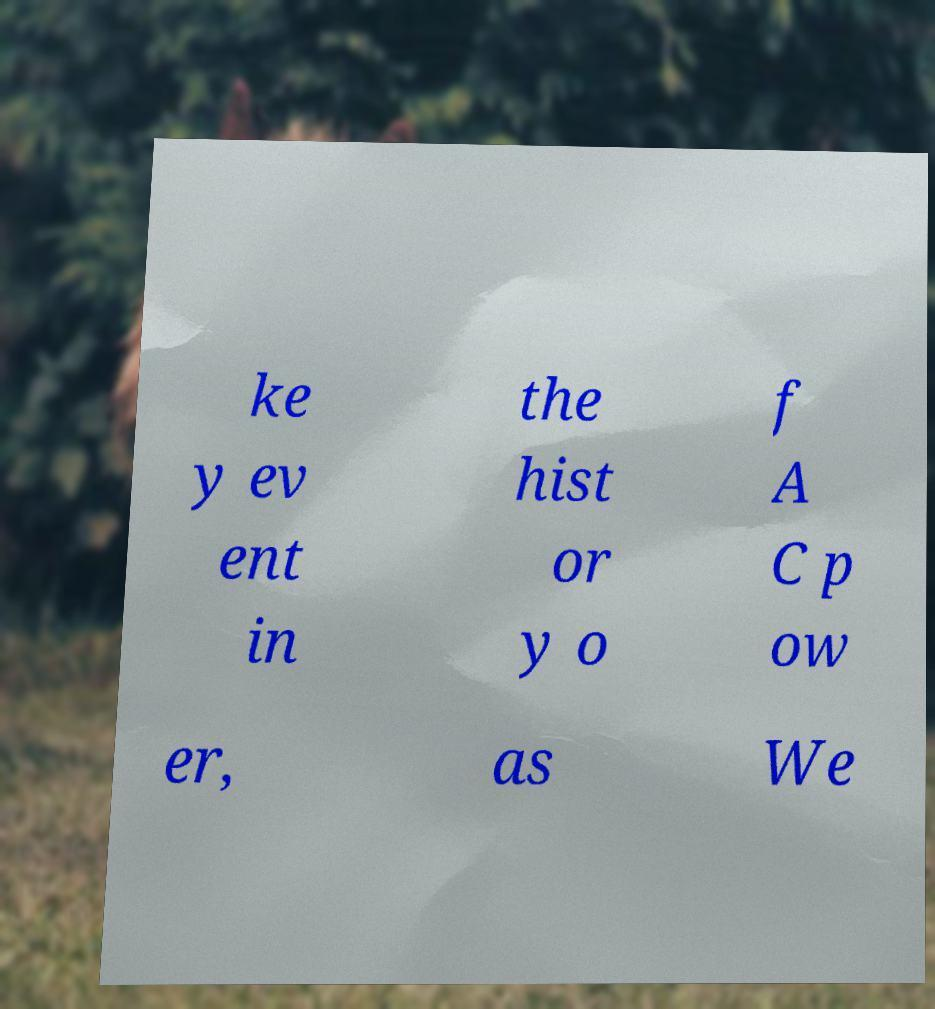Please read and relay the text visible in this image. What does it say? ke y ev ent in the hist or y o f A C p ow er, as We 